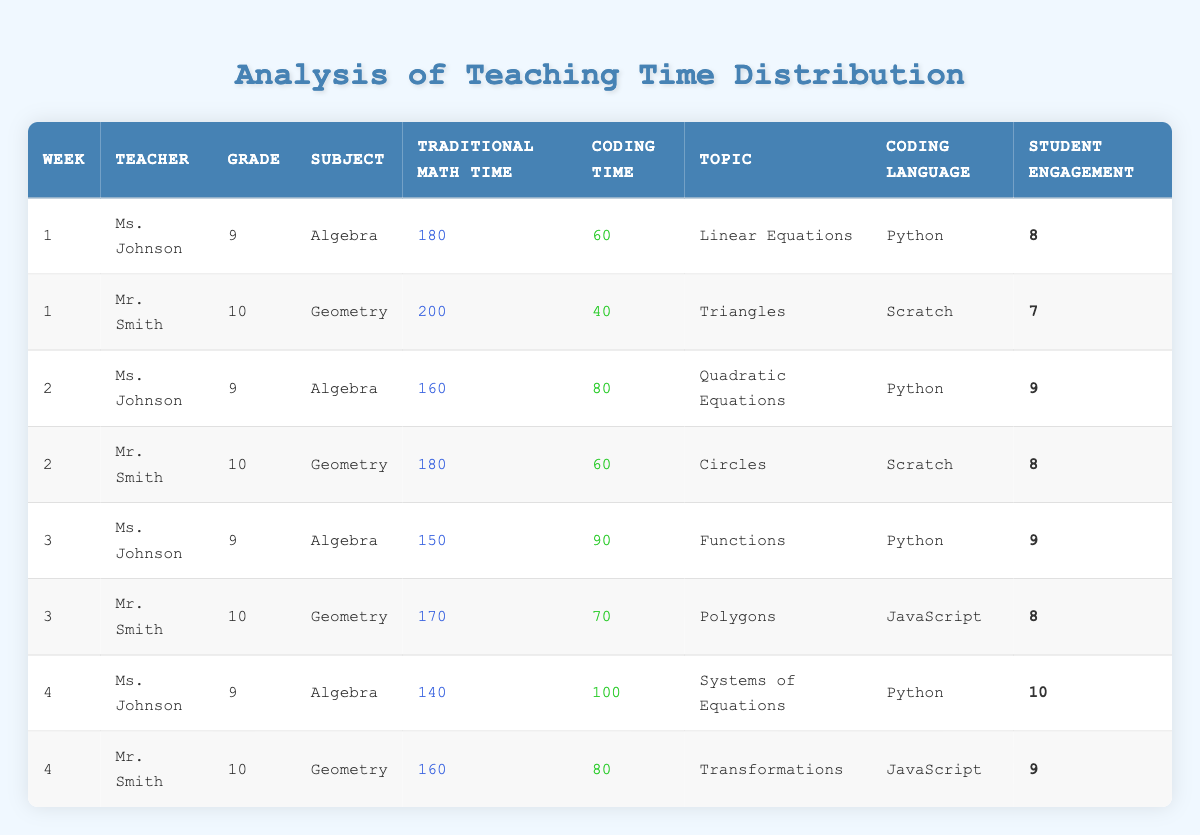What is the total Traditional Math Time for Week 1? In Week 1, Ms. Johnson has 180 minutes and Mr. Smith has 200 minutes of Traditional Math Time. Summing these values: 180 + 200 = 380.
Answer: 380 What was the Coding Time for Ms. Johnson in Week 3? In Week 3, Ms. Johnson has 90 minutes of Coding Time according to the table.
Answer: 90 How much more Traditional Math Time did Mr. Smith allocate in Week 2 compared to Week 1? In Week 1, Mr. Smith allocated 200 minutes, and in Week 2, he allocated 180 minutes. The difference is 200 - 180 = 20 minutes.
Answer: 20 What is the average Student Engagement for the Coding Language Python across all weeks? Ms. Johnson has student engagement scores of 8, 9, 9, and 10, which sum to 36. Dividing by the number of weeks (4), the average is 36 / 4 = 9.
Answer: 9 Did Mr. Smith use more Coding Time than Traditional Math Time in any week? In the table, Mr. Smith’s Coding Time is less than his Traditional Math Time in every instance. Therefore, the answer is no.
Answer: No Which teacher had the highest total Coding Time across all weeks? Calculating the total Coding Time: Ms. Johnson has 60 + 80 + 90 + 100 = 330; Mr. Smith has 40 + 60 + 70 + 80 = 250. Ms. Johnson has the higher total, so the answer is Ms. Johnson.
Answer: Ms. Johnson What is the total Coding Time for all weeks combined? Summing the Coding Time for each teacher across all weeks: 60 + 40 + 80 + 60 + 90 + 70 + 100 + 80 = 580.
Answer: 580 Was there a week where Ms. Johnson's Traditional Math Time fell below 150 minutes? In the table, her Traditional Math Time data points show she allocated 140 minutes in Week 4, which is below 150. Therefore, the answer is yes.
Answer: Yes 